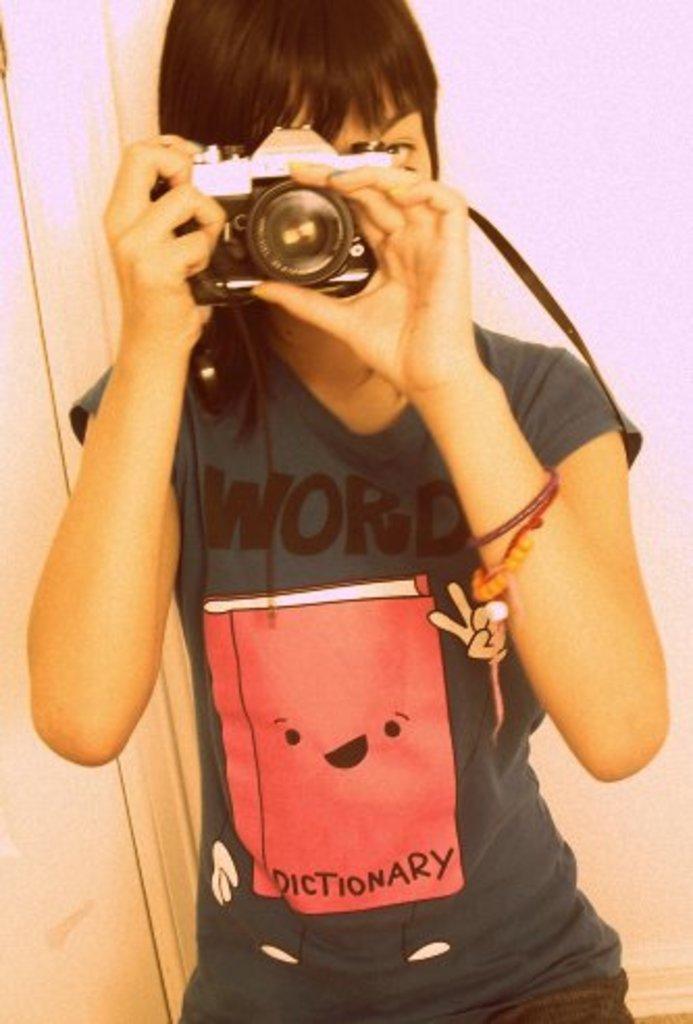Please provide a concise description of this image. In this image i can see a person holding a camera. 